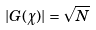<formula> <loc_0><loc_0><loc_500><loc_500>| G ( \chi ) | = \sqrt { N }</formula> 